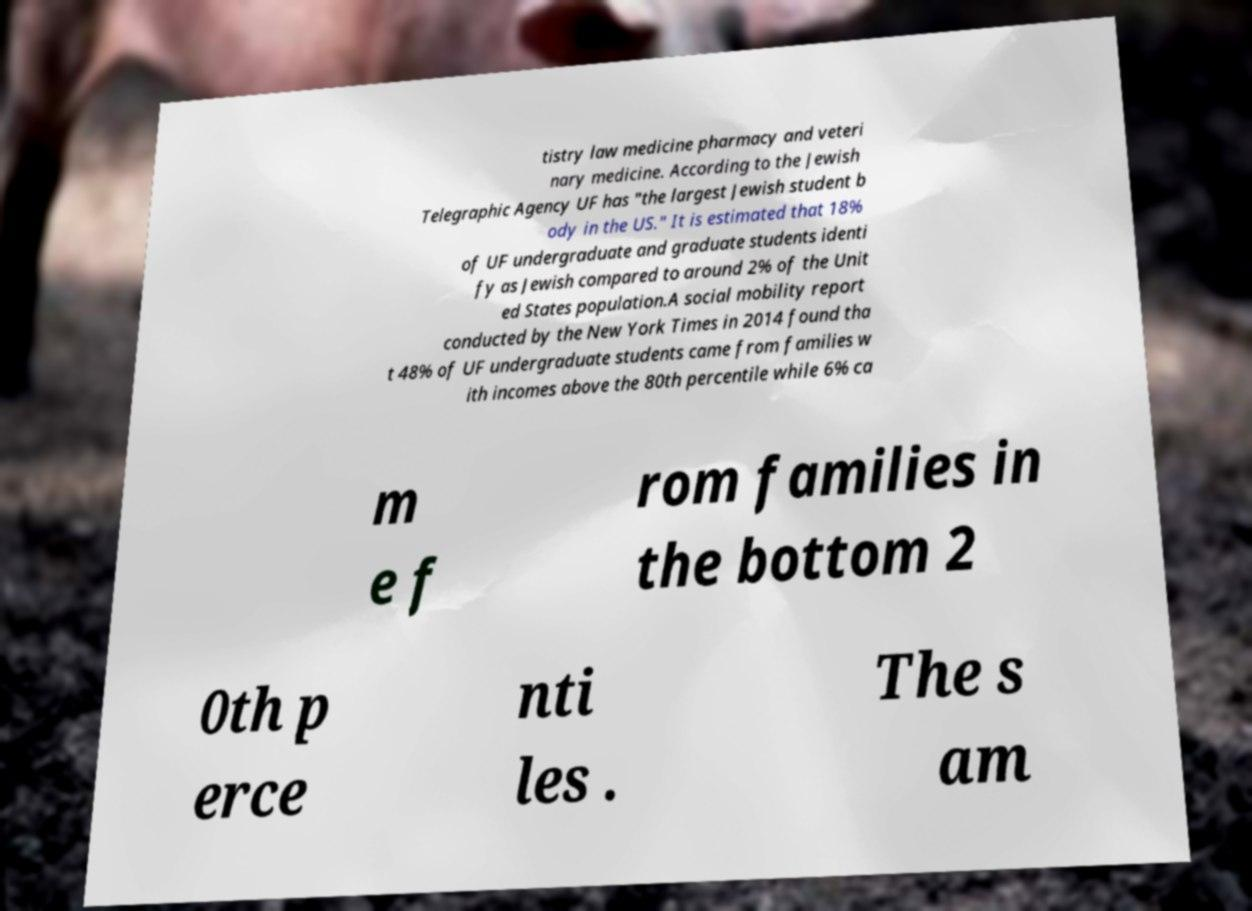For documentation purposes, I need the text within this image transcribed. Could you provide that? tistry law medicine pharmacy and veteri nary medicine. According to the Jewish Telegraphic Agency UF has "the largest Jewish student b ody in the US." It is estimated that 18% of UF undergraduate and graduate students identi fy as Jewish compared to around 2% of the Unit ed States population.A social mobility report conducted by the New York Times in 2014 found tha t 48% of UF undergraduate students came from families w ith incomes above the 80th percentile while 6% ca m e f rom families in the bottom 2 0th p erce nti les . The s am 